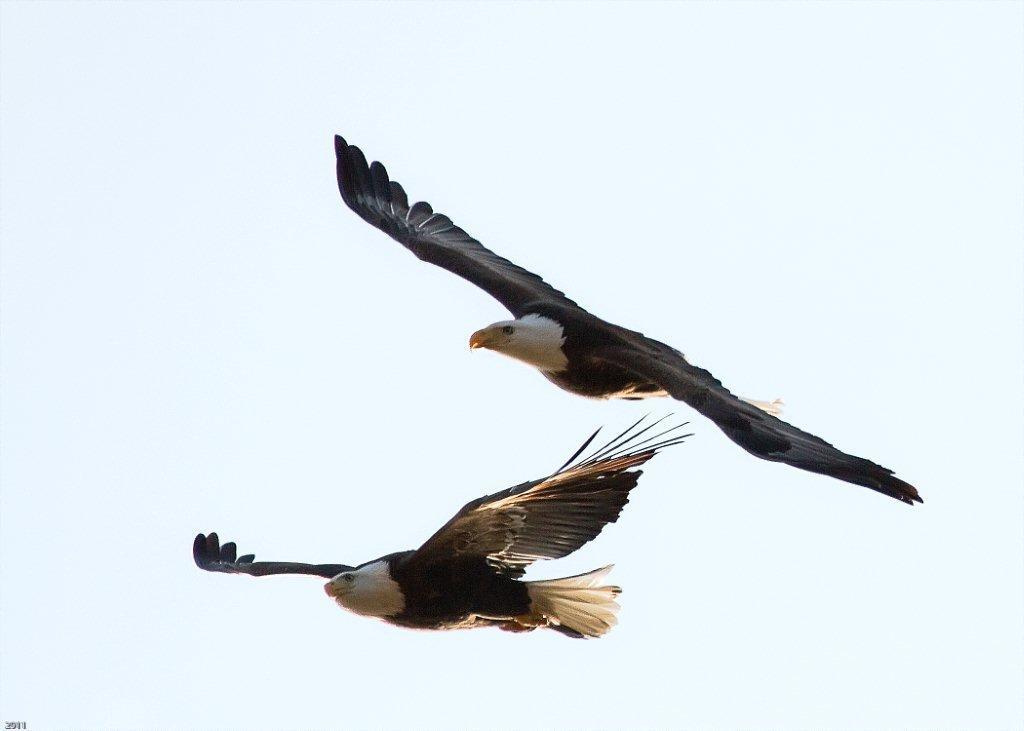In one or two sentences, can you explain what this image depicts? In this picture in the middle, we can see two birds flying in the air. In the background, we can see a sky. 